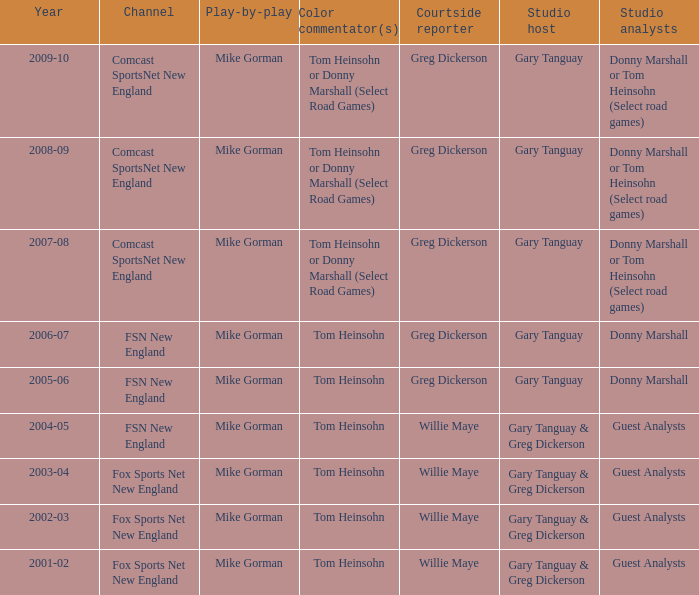Who is the sideline journalist for the year 2009-10? Greg Dickerson. 